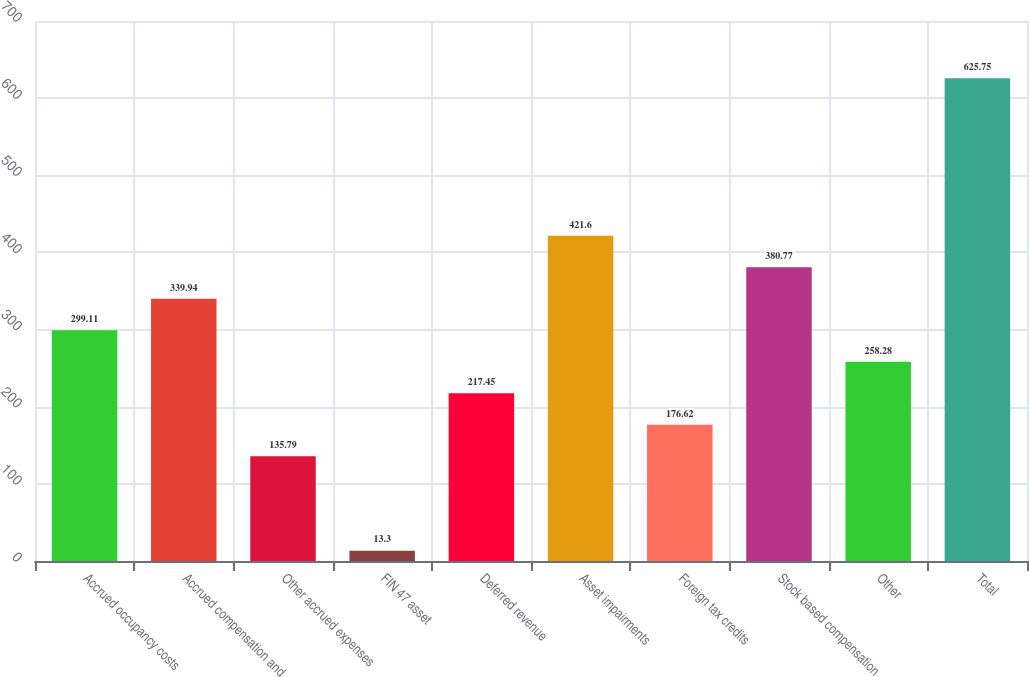Convert chart to OTSL. <chart><loc_0><loc_0><loc_500><loc_500><bar_chart><fcel>Accrued occupancy costs<fcel>Accrued compensation and<fcel>Other accrued expenses<fcel>FIN 47 asset<fcel>Deferred revenue<fcel>Asset impairments<fcel>Foreign tax credits<fcel>Stock based compensation<fcel>Other<fcel>Total<nl><fcel>299.11<fcel>339.94<fcel>135.79<fcel>13.3<fcel>217.45<fcel>421.6<fcel>176.62<fcel>380.77<fcel>258.28<fcel>625.75<nl></chart> 